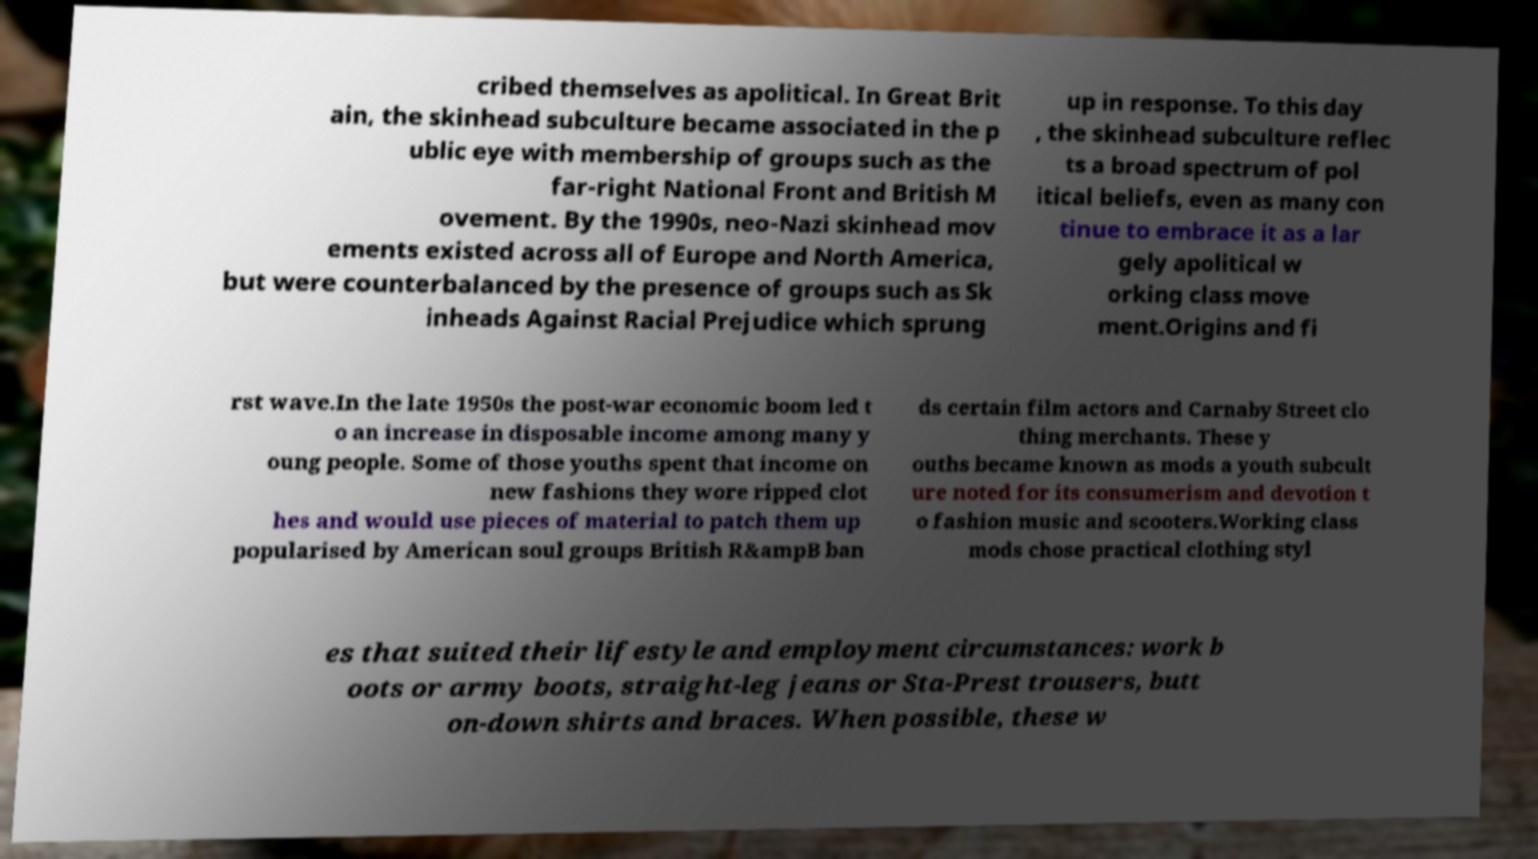Can you accurately transcribe the text from the provided image for me? cribed themselves as apolitical. In Great Brit ain, the skinhead subculture became associated in the p ublic eye with membership of groups such as the far-right National Front and British M ovement. By the 1990s, neo-Nazi skinhead mov ements existed across all of Europe and North America, but were counterbalanced by the presence of groups such as Sk inheads Against Racial Prejudice which sprung up in response. To this day , the skinhead subculture reflec ts a broad spectrum of pol itical beliefs, even as many con tinue to embrace it as a lar gely apolitical w orking class move ment.Origins and fi rst wave.In the late 1950s the post-war economic boom led t o an increase in disposable income among many y oung people. Some of those youths spent that income on new fashions they wore ripped clot hes and would use pieces of material to patch them up popularised by American soul groups British R&ampB ban ds certain film actors and Carnaby Street clo thing merchants. These y ouths became known as mods a youth subcult ure noted for its consumerism and devotion t o fashion music and scooters.Working class mods chose practical clothing styl es that suited their lifestyle and employment circumstances: work b oots or army boots, straight-leg jeans or Sta-Prest trousers, butt on-down shirts and braces. When possible, these w 